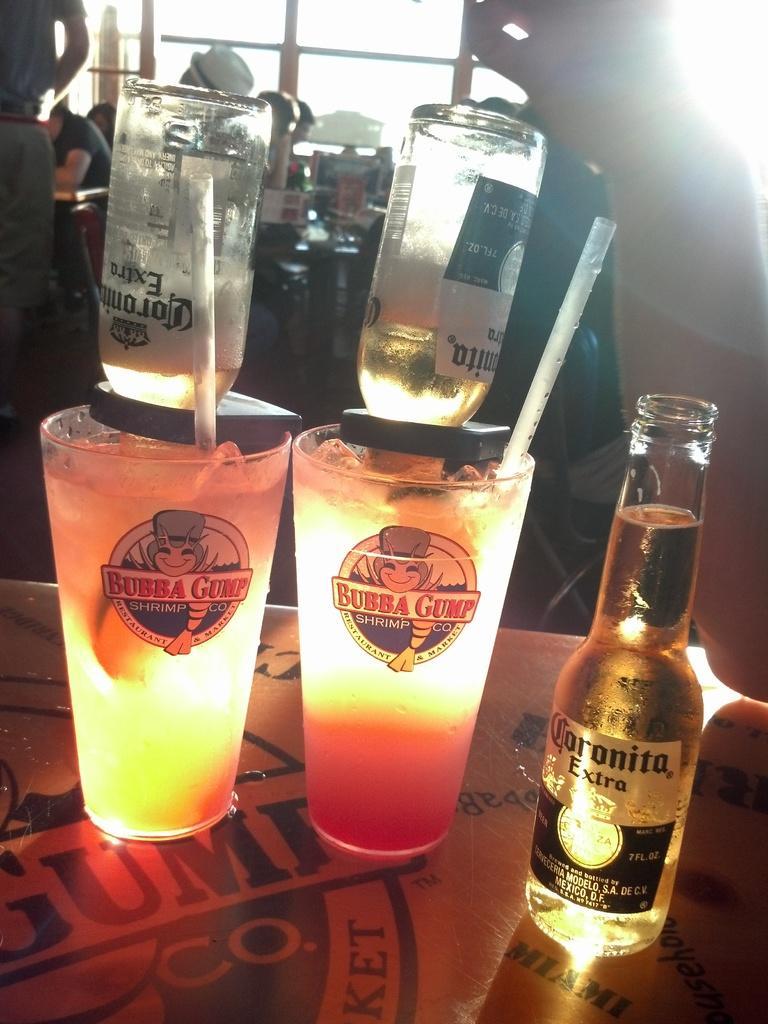Can you describe this image briefly? On the table there are two glasses with liquid In it. On the glasses there are bottles and straw. To the right side there is a bottle with wine in it. And in the background there are some people sitting. And to the top left corner there is a man standing. 